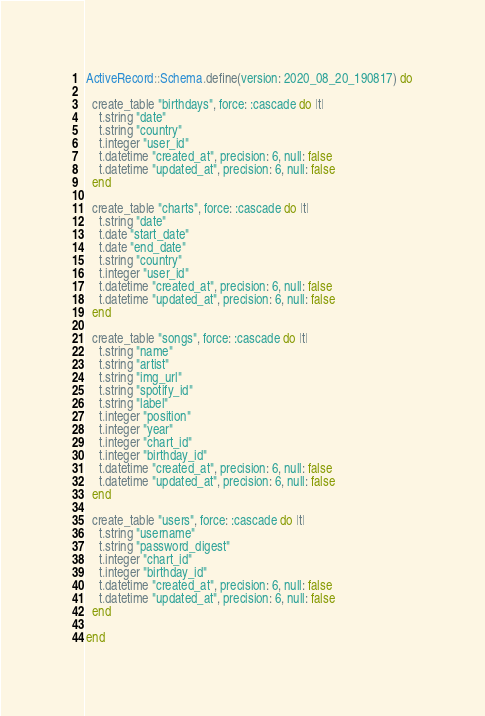<code> <loc_0><loc_0><loc_500><loc_500><_Ruby_>
ActiveRecord::Schema.define(version: 2020_08_20_190817) do

  create_table "birthdays", force: :cascade do |t|
    t.string "date"
    t.string "country"
    t.integer "user_id"
    t.datetime "created_at", precision: 6, null: false
    t.datetime "updated_at", precision: 6, null: false
  end

  create_table "charts", force: :cascade do |t|
    t.string "date"
    t.date "start_date"
    t.date "end_date"
    t.string "country"
    t.integer "user_id"
    t.datetime "created_at", precision: 6, null: false
    t.datetime "updated_at", precision: 6, null: false
  end

  create_table "songs", force: :cascade do |t|
    t.string "name"
    t.string "artist"
    t.string "img_url"
    t.string "spotify_id"
    t.string "label"
    t.integer "position"
    t.integer "year"
    t.integer "chart_id"
    t.integer "birthday_id"
    t.datetime "created_at", precision: 6, null: false
    t.datetime "updated_at", precision: 6, null: false
  end

  create_table "users", force: :cascade do |t|
    t.string "username"
    t.string "password_digest"
    t.integer "chart_id"
    t.integer "birthday_id"
    t.datetime "created_at", precision: 6, null: false
    t.datetime "updated_at", precision: 6, null: false
  end

end
</code> 